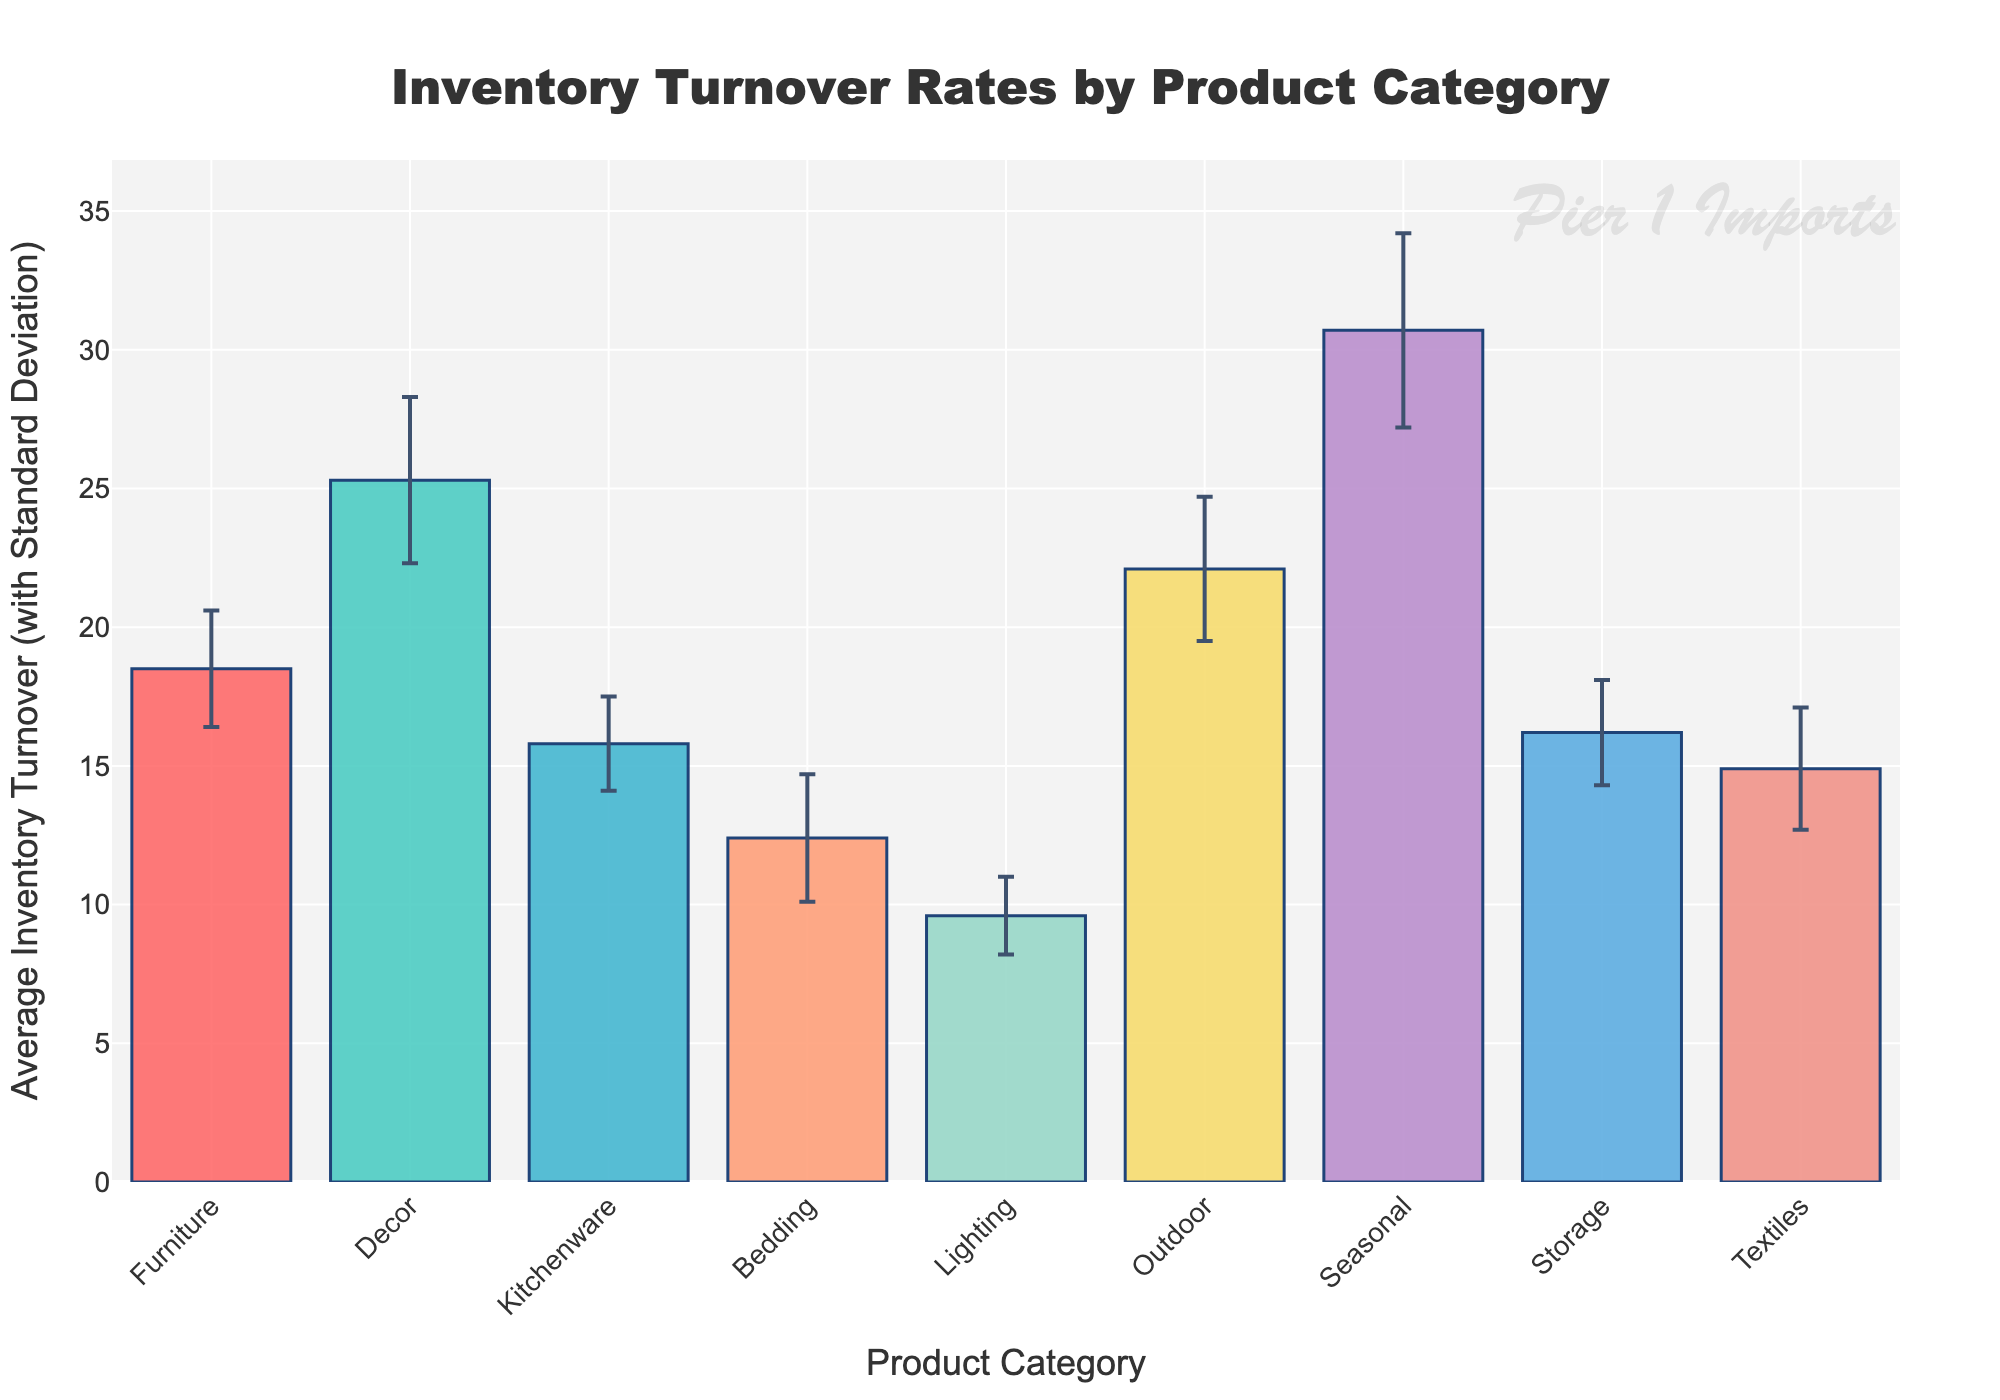What's the title of the figure? The title of the figure is displayed prominently at the top in a larger font size and boldface, making it easy to identify.
Answer: Inventory Turnover Rates by Product Category Which product category has the highest average inventory turnover rate? By looking at the height of the bars, the tallest bar represents the category with the highest turnover rate.
Answer: Seasonal What is the average inventory turnover rate of Kitchenware? The height of the bar for Kitchenware corresponds to its average inventory turnover rate, indicated by the y-axis.
Answer: 15.8 What is the difference in average inventory turnover rates between Furniture and Lighting? Subtract the turnover rate of Lighting from that of Furniture: 18.5 - 9.6.
Answer: 8.9 Which category has the lowest standard deviation in inventory turnover? The category with the smallest error bar, which represents the standard deviation, indicates the lowest variance.
Answer: Lighting How many product categories have an average inventory turnover rate above 20? Count the bars that reach above the y-axis value of 20.
Answer: 3 (Decor, Outdoor, Seasonal) What is the range of values for the y-axis? The y-axis range is derived from the minimum and maximum values shown, along with the headroom provided.
Answer: 0 to approximately 37 Between Bedding and Textiles, which category has a higher inventory turnover rate? By comparing the heights of the bars for Bedding and Textiles.
Answer: Textiles What's the standard deviation of Decor's inventory turnover rate? The error bar height for Decor points out its standard deviation, as indicated in the legend or figure.
Answer: 3.0 How does the inventory turnover rate of Storage compare to Outdoor? Compare the heights of the bars for Storage and Outdoor and check if Storage has a lower rate than Outdoor.
Answer: Storage has a lower rate 